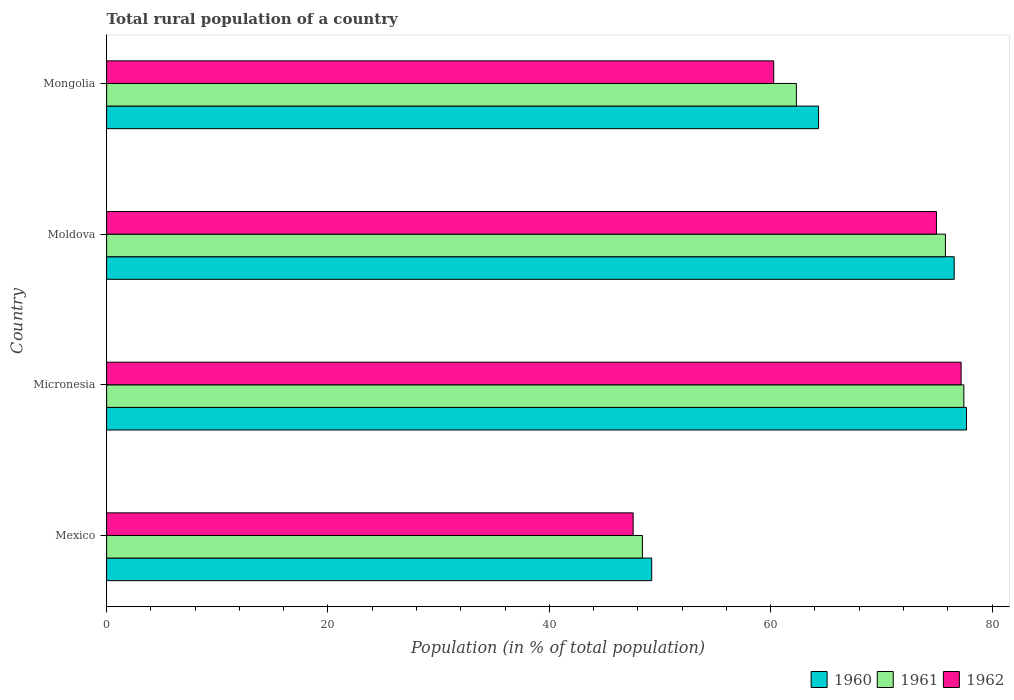How many groups of bars are there?
Keep it short and to the point. 4. Are the number of bars on each tick of the Y-axis equal?
Your answer should be compact. Yes. How many bars are there on the 2nd tick from the top?
Keep it short and to the point. 3. What is the label of the 2nd group of bars from the top?
Offer a very short reply. Moldova. In how many cases, is the number of bars for a given country not equal to the number of legend labels?
Your answer should be very brief. 0. What is the rural population in 1961 in Mexico?
Ensure brevity in your answer.  48.41. Across all countries, what is the maximum rural population in 1962?
Keep it short and to the point. 77.2. Across all countries, what is the minimum rural population in 1960?
Give a very brief answer. 49.25. In which country was the rural population in 1961 maximum?
Provide a succinct answer. Micronesia. In which country was the rural population in 1960 minimum?
Offer a terse response. Mexico. What is the total rural population in 1962 in the graph?
Offer a terse response. 260.02. What is the difference between the rural population in 1960 in Mexico and that in Moldova?
Ensure brevity in your answer.  -27.33. What is the difference between the rural population in 1962 in Mongolia and the rural population in 1961 in Mexico?
Provide a succinct answer. 11.86. What is the average rural population in 1961 per country?
Your answer should be compact. 65.99. What is the difference between the rural population in 1962 and rural population in 1960 in Micronesia?
Offer a terse response. -0.48. In how many countries, is the rural population in 1961 greater than 76 %?
Your answer should be very brief. 1. What is the ratio of the rural population in 1960 in Mexico to that in Mongolia?
Your answer should be compact. 0.77. What is the difference between the highest and the second highest rural population in 1962?
Provide a short and direct response. 2.23. What is the difference between the highest and the lowest rural population in 1961?
Provide a short and direct response. 29.04. What does the 2nd bar from the top in Moldova represents?
Give a very brief answer. 1961. What does the 2nd bar from the bottom in Mongolia represents?
Give a very brief answer. 1961. Is it the case that in every country, the sum of the rural population in 1961 and rural population in 1960 is greater than the rural population in 1962?
Offer a terse response. Yes. How many countries are there in the graph?
Provide a short and direct response. 4. Does the graph contain any zero values?
Ensure brevity in your answer.  No. How many legend labels are there?
Provide a succinct answer. 3. How are the legend labels stacked?
Provide a short and direct response. Horizontal. What is the title of the graph?
Provide a succinct answer. Total rural population of a country. What is the label or title of the X-axis?
Offer a very short reply. Population (in % of total population). What is the Population (in % of total population) in 1960 in Mexico?
Your answer should be very brief. 49.25. What is the Population (in % of total population) of 1961 in Mexico?
Provide a short and direct response. 48.41. What is the Population (in % of total population) of 1962 in Mexico?
Make the answer very short. 47.57. What is the Population (in % of total population) in 1960 in Micronesia?
Your answer should be very brief. 77.69. What is the Population (in % of total population) of 1961 in Micronesia?
Keep it short and to the point. 77.45. What is the Population (in % of total population) in 1962 in Micronesia?
Offer a terse response. 77.2. What is the Population (in % of total population) in 1960 in Moldova?
Your answer should be very brief. 76.58. What is the Population (in % of total population) of 1961 in Moldova?
Offer a terse response. 75.78. What is the Population (in % of total population) of 1962 in Moldova?
Your response must be concise. 74.97. What is the Population (in % of total population) in 1960 in Mongolia?
Ensure brevity in your answer.  64.32. What is the Population (in % of total population) of 1961 in Mongolia?
Make the answer very short. 62.32. What is the Population (in % of total population) of 1962 in Mongolia?
Your answer should be compact. 60.27. Across all countries, what is the maximum Population (in % of total population) in 1960?
Make the answer very short. 77.69. Across all countries, what is the maximum Population (in % of total population) of 1961?
Give a very brief answer. 77.45. Across all countries, what is the maximum Population (in % of total population) of 1962?
Keep it short and to the point. 77.2. Across all countries, what is the minimum Population (in % of total population) in 1960?
Your answer should be very brief. 49.25. Across all countries, what is the minimum Population (in % of total population) in 1961?
Keep it short and to the point. 48.41. Across all countries, what is the minimum Population (in % of total population) of 1962?
Your answer should be compact. 47.57. What is the total Population (in % of total population) of 1960 in the graph?
Your response must be concise. 267.83. What is the total Population (in % of total population) of 1961 in the graph?
Keep it short and to the point. 263.96. What is the total Population (in % of total population) in 1962 in the graph?
Your answer should be very brief. 260.02. What is the difference between the Population (in % of total population) in 1960 in Mexico and that in Micronesia?
Give a very brief answer. -28.44. What is the difference between the Population (in % of total population) of 1961 in Mexico and that in Micronesia?
Offer a terse response. -29.04. What is the difference between the Population (in % of total population) in 1962 in Mexico and that in Micronesia?
Provide a succinct answer. -29.63. What is the difference between the Population (in % of total population) of 1960 in Mexico and that in Moldova?
Your response must be concise. -27.33. What is the difference between the Population (in % of total population) of 1961 in Mexico and that in Moldova?
Your response must be concise. -27.37. What is the difference between the Population (in % of total population) in 1962 in Mexico and that in Moldova?
Offer a very short reply. -27.4. What is the difference between the Population (in % of total population) of 1960 in Mexico and that in Mongolia?
Offer a very short reply. -15.07. What is the difference between the Population (in % of total population) in 1961 in Mexico and that in Mongolia?
Your answer should be compact. -13.91. What is the difference between the Population (in % of total population) of 1962 in Mexico and that in Mongolia?
Offer a terse response. -12.7. What is the difference between the Population (in % of total population) of 1960 in Micronesia and that in Moldova?
Offer a very short reply. 1.11. What is the difference between the Population (in % of total population) in 1961 in Micronesia and that in Moldova?
Offer a terse response. 1.66. What is the difference between the Population (in % of total population) in 1962 in Micronesia and that in Moldova?
Make the answer very short. 2.23. What is the difference between the Population (in % of total population) in 1960 in Micronesia and that in Mongolia?
Provide a short and direct response. 13.37. What is the difference between the Population (in % of total population) in 1961 in Micronesia and that in Mongolia?
Your answer should be compact. 15.13. What is the difference between the Population (in % of total population) in 1962 in Micronesia and that in Mongolia?
Ensure brevity in your answer.  16.93. What is the difference between the Population (in % of total population) in 1960 in Moldova and that in Mongolia?
Your answer should be very brief. 12.26. What is the difference between the Population (in % of total population) in 1961 in Moldova and that in Mongolia?
Your answer should be compact. 13.47. What is the difference between the Population (in % of total population) in 1962 in Moldova and that in Mongolia?
Provide a succinct answer. 14.7. What is the difference between the Population (in % of total population) in 1960 in Mexico and the Population (in % of total population) in 1961 in Micronesia?
Keep it short and to the point. -28.2. What is the difference between the Population (in % of total population) in 1960 in Mexico and the Population (in % of total population) in 1962 in Micronesia?
Your response must be concise. -27.96. What is the difference between the Population (in % of total population) in 1961 in Mexico and the Population (in % of total population) in 1962 in Micronesia?
Keep it short and to the point. -28.79. What is the difference between the Population (in % of total population) in 1960 in Mexico and the Population (in % of total population) in 1961 in Moldova?
Make the answer very short. -26.54. What is the difference between the Population (in % of total population) of 1960 in Mexico and the Population (in % of total population) of 1962 in Moldova?
Provide a short and direct response. -25.73. What is the difference between the Population (in % of total population) of 1961 in Mexico and the Population (in % of total population) of 1962 in Moldova?
Offer a very short reply. -26.56. What is the difference between the Population (in % of total population) of 1960 in Mexico and the Population (in % of total population) of 1961 in Mongolia?
Your response must be concise. -13.07. What is the difference between the Population (in % of total population) of 1960 in Mexico and the Population (in % of total population) of 1962 in Mongolia?
Offer a very short reply. -11.02. What is the difference between the Population (in % of total population) in 1961 in Mexico and the Population (in % of total population) in 1962 in Mongolia?
Your answer should be very brief. -11.86. What is the difference between the Population (in % of total population) in 1960 in Micronesia and the Population (in % of total population) in 1961 in Moldova?
Your answer should be compact. 1.9. What is the difference between the Population (in % of total population) in 1960 in Micronesia and the Population (in % of total population) in 1962 in Moldova?
Your answer should be compact. 2.71. What is the difference between the Population (in % of total population) of 1961 in Micronesia and the Population (in % of total population) of 1962 in Moldova?
Offer a terse response. 2.47. What is the difference between the Population (in % of total population) of 1960 in Micronesia and the Population (in % of total population) of 1961 in Mongolia?
Your answer should be compact. 15.37. What is the difference between the Population (in % of total population) in 1960 in Micronesia and the Population (in % of total population) in 1962 in Mongolia?
Provide a succinct answer. 17.42. What is the difference between the Population (in % of total population) of 1961 in Micronesia and the Population (in % of total population) of 1962 in Mongolia?
Your answer should be compact. 17.18. What is the difference between the Population (in % of total population) in 1960 in Moldova and the Population (in % of total population) in 1961 in Mongolia?
Your answer should be very brief. 14.26. What is the difference between the Population (in % of total population) of 1960 in Moldova and the Population (in % of total population) of 1962 in Mongolia?
Make the answer very short. 16.31. What is the difference between the Population (in % of total population) of 1961 in Moldova and the Population (in % of total population) of 1962 in Mongolia?
Your answer should be very brief. 15.51. What is the average Population (in % of total population) of 1960 per country?
Your answer should be compact. 66.96. What is the average Population (in % of total population) of 1961 per country?
Your response must be concise. 65.99. What is the average Population (in % of total population) of 1962 per country?
Ensure brevity in your answer.  65. What is the difference between the Population (in % of total population) in 1960 and Population (in % of total population) in 1961 in Mexico?
Keep it short and to the point. 0.84. What is the difference between the Population (in % of total population) in 1960 and Population (in % of total population) in 1962 in Mexico?
Make the answer very short. 1.68. What is the difference between the Population (in % of total population) of 1961 and Population (in % of total population) of 1962 in Mexico?
Give a very brief answer. 0.84. What is the difference between the Population (in % of total population) in 1960 and Population (in % of total population) in 1961 in Micronesia?
Ensure brevity in your answer.  0.24. What is the difference between the Population (in % of total population) in 1960 and Population (in % of total population) in 1962 in Micronesia?
Your answer should be compact. 0.48. What is the difference between the Population (in % of total population) in 1961 and Population (in % of total population) in 1962 in Micronesia?
Your response must be concise. 0.24. What is the difference between the Population (in % of total population) in 1960 and Population (in % of total population) in 1961 in Moldova?
Your answer should be very brief. 0.79. What is the difference between the Population (in % of total population) in 1960 and Population (in % of total population) in 1962 in Moldova?
Provide a succinct answer. 1.6. What is the difference between the Population (in % of total population) in 1961 and Population (in % of total population) in 1962 in Moldova?
Keep it short and to the point. 0.81. What is the difference between the Population (in % of total population) of 1960 and Population (in % of total population) of 1961 in Mongolia?
Ensure brevity in your answer.  2. What is the difference between the Population (in % of total population) in 1960 and Population (in % of total population) in 1962 in Mongolia?
Provide a short and direct response. 4.05. What is the difference between the Population (in % of total population) of 1961 and Population (in % of total population) of 1962 in Mongolia?
Provide a short and direct response. 2.05. What is the ratio of the Population (in % of total population) of 1960 in Mexico to that in Micronesia?
Your answer should be very brief. 0.63. What is the ratio of the Population (in % of total population) in 1961 in Mexico to that in Micronesia?
Provide a succinct answer. 0.63. What is the ratio of the Population (in % of total population) of 1962 in Mexico to that in Micronesia?
Your answer should be very brief. 0.62. What is the ratio of the Population (in % of total population) of 1960 in Mexico to that in Moldova?
Offer a very short reply. 0.64. What is the ratio of the Population (in % of total population) in 1961 in Mexico to that in Moldova?
Offer a very short reply. 0.64. What is the ratio of the Population (in % of total population) of 1962 in Mexico to that in Moldova?
Your response must be concise. 0.63. What is the ratio of the Population (in % of total population) of 1960 in Mexico to that in Mongolia?
Your answer should be compact. 0.77. What is the ratio of the Population (in % of total population) in 1961 in Mexico to that in Mongolia?
Give a very brief answer. 0.78. What is the ratio of the Population (in % of total population) of 1962 in Mexico to that in Mongolia?
Keep it short and to the point. 0.79. What is the ratio of the Population (in % of total population) of 1960 in Micronesia to that in Moldova?
Provide a succinct answer. 1.01. What is the ratio of the Population (in % of total population) of 1961 in Micronesia to that in Moldova?
Offer a terse response. 1.02. What is the ratio of the Population (in % of total population) in 1962 in Micronesia to that in Moldova?
Make the answer very short. 1.03. What is the ratio of the Population (in % of total population) of 1960 in Micronesia to that in Mongolia?
Provide a short and direct response. 1.21. What is the ratio of the Population (in % of total population) of 1961 in Micronesia to that in Mongolia?
Your response must be concise. 1.24. What is the ratio of the Population (in % of total population) in 1962 in Micronesia to that in Mongolia?
Your answer should be compact. 1.28. What is the ratio of the Population (in % of total population) in 1960 in Moldova to that in Mongolia?
Ensure brevity in your answer.  1.19. What is the ratio of the Population (in % of total population) of 1961 in Moldova to that in Mongolia?
Make the answer very short. 1.22. What is the ratio of the Population (in % of total population) of 1962 in Moldova to that in Mongolia?
Your response must be concise. 1.24. What is the difference between the highest and the second highest Population (in % of total population) of 1960?
Offer a very short reply. 1.11. What is the difference between the highest and the second highest Population (in % of total population) in 1961?
Provide a short and direct response. 1.66. What is the difference between the highest and the second highest Population (in % of total population) of 1962?
Your response must be concise. 2.23. What is the difference between the highest and the lowest Population (in % of total population) of 1960?
Provide a short and direct response. 28.44. What is the difference between the highest and the lowest Population (in % of total population) in 1961?
Provide a short and direct response. 29.04. What is the difference between the highest and the lowest Population (in % of total population) of 1962?
Your response must be concise. 29.63. 